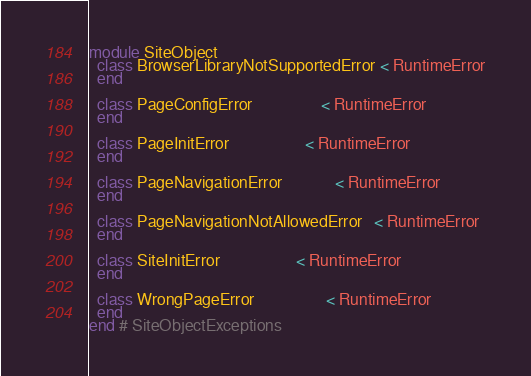Convert code to text. <code><loc_0><loc_0><loc_500><loc_500><_Ruby_>module SiteObject
  class BrowserLibraryNotSupportedError < RuntimeError
  end

  class PageConfigError                 < RuntimeError
  end

  class PageInitError                   < RuntimeError
  end

  class PageNavigationError             < RuntimeError
  end

  class PageNavigationNotAllowedError   < RuntimeError
  end

  class SiteInitError                   < RuntimeError
  end

  class WrongPageError                  < RuntimeError
  end
end # SiteObjectExceptions
</code> 